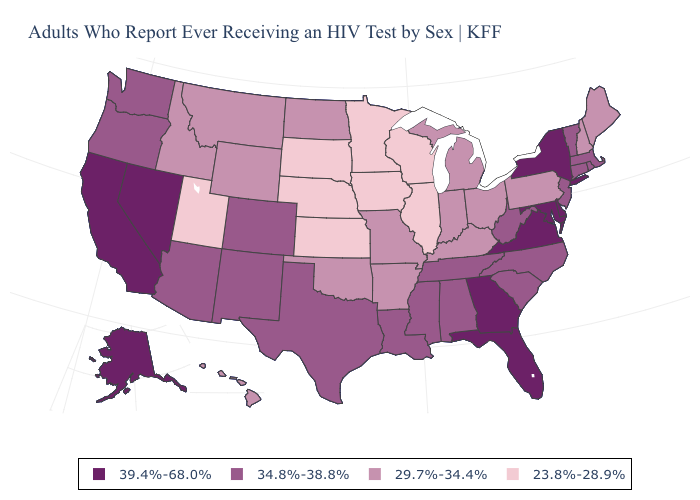Which states have the lowest value in the West?
Be succinct. Utah. What is the value of Iowa?
Concise answer only. 23.8%-28.9%. Does the first symbol in the legend represent the smallest category?
Write a very short answer. No. Name the states that have a value in the range 34.8%-38.8%?
Answer briefly. Alabama, Arizona, Colorado, Connecticut, Louisiana, Massachusetts, Mississippi, New Jersey, New Mexico, North Carolina, Oregon, Rhode Island, South Carolina, Tennessee, Texas, Vermont, Washington, West Virginia. What is the lowest value in states that border Rhode Island?
Short answer required. 34.8%-38.8%. Does Washington have a lower value than Maryland?
Short answer required. Yes. Name the states that have a value in the range 23.8%-28.9%?
Answer briefly. Illinois, Iowa, Kansas, Minnesota, Nebraska, South Dakota, Utah, Wisconsin. Which states have the lowest value in the USA?
Concise answer only. Illinois, Iowa, Kansas, Minnesota, Nebraska, South Dakota, Utah, Wisconsin. Which states have the highest value in the USA?
Give a very brief answer. Alaska, California, Delaware, Florida, Georgia, Maryland, Nevada, New York, Virginia. Does the first symbol in the legend represent the smallest category?
Give a very brief answer. No. Name the states that have a value in the range 39.4%-68.0%?
Answer briefly. Alaska, California, Delaware, Florida, Georgia, Maryland, Nevada, New York, Virginia. Among the states that border Iowa , does Missouri have the highest value?
Short answer required. Yes. What is the highest value in the MidWest ?
Short answer required. 29.7%-34.4%. Among the states that border Ohio , does Pennsylvania have the highest value?
Keep it brief. No. Name the states that have a value in the range 23.8%-28.9%?
Answer briefly. Illinois, Iowa, Kansas, Minnesota, Nebraska, South Dakota, Utah, Wisconsin. 